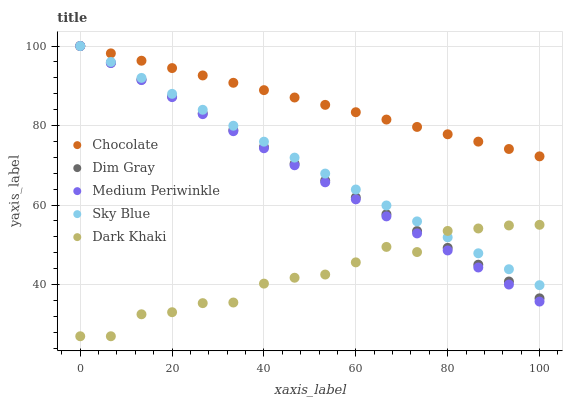Does Dark Khaki have the minimum area under the curve?
Answer yes or no. Yes. Does Chocolate have the maximum area under the curve?
Answer yes or no. Yes. Does Sky Blue have the minimum area under the curve?
Answer yes or no. No. Does Sky Blue have the maximum area under the curve?
Answer yes or no. No. Is Dim Gray the smoothest?
Answer yes or no. Yes. Is Dark Khaki the roughest?
Answer yes or no. Yes. Is Sky Blue the smoothest?
Answer yes or no. No. Is Sky Blue the roughest?
Answer yes or no. No. Does Dark Khaki have the lowest value?
Answer yes or no. Yes. Does Sky Blue have the lowest value?
Answer yes or no. No. Does Chocolate have the highest value?
Answer yes or no. Yes. Is Dark Khaki less than Chocolate?
Answer yes or no. Yes. Is Chocolate greater than Dark Khaki?
Answer yes or no. Yes. Does Dim Gray intersect Sky Blue?
Answer yes or no. Yes. Is Dim Gray less than Sky Blue?
Answer yes or no. No. Is Dim Gray greater than Sky Blue?
Answer yes or no. No. Does Dark Khaki intersect Chocolate?
Answer yes or no. No. 